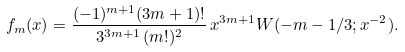<formula> <loc_0><loc_0><loc_500><loc_500>f _ { m } ( x ) = \frac { ( - 1 ) ^ { m + 1 } ( 3 m + 1 ) ! } { 3 ^ { 3 m + 1 } \, ( m ! ) ^ { 2 } } \, x ^ { 3 m + 1 } W ( - m - 1 / 3 ; x ^ { - 2 } ) .</formula> 